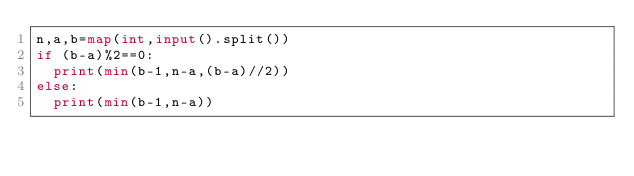<code> <loc_0><loc_0><loc_500><loc_500><_Python_>n,a,b=map(int,input().split())
if (b-a)%2==0:
	print(min(b-1,n-a,(b-a)//2))
else:
	print(min(b-1,n-a))</code> 